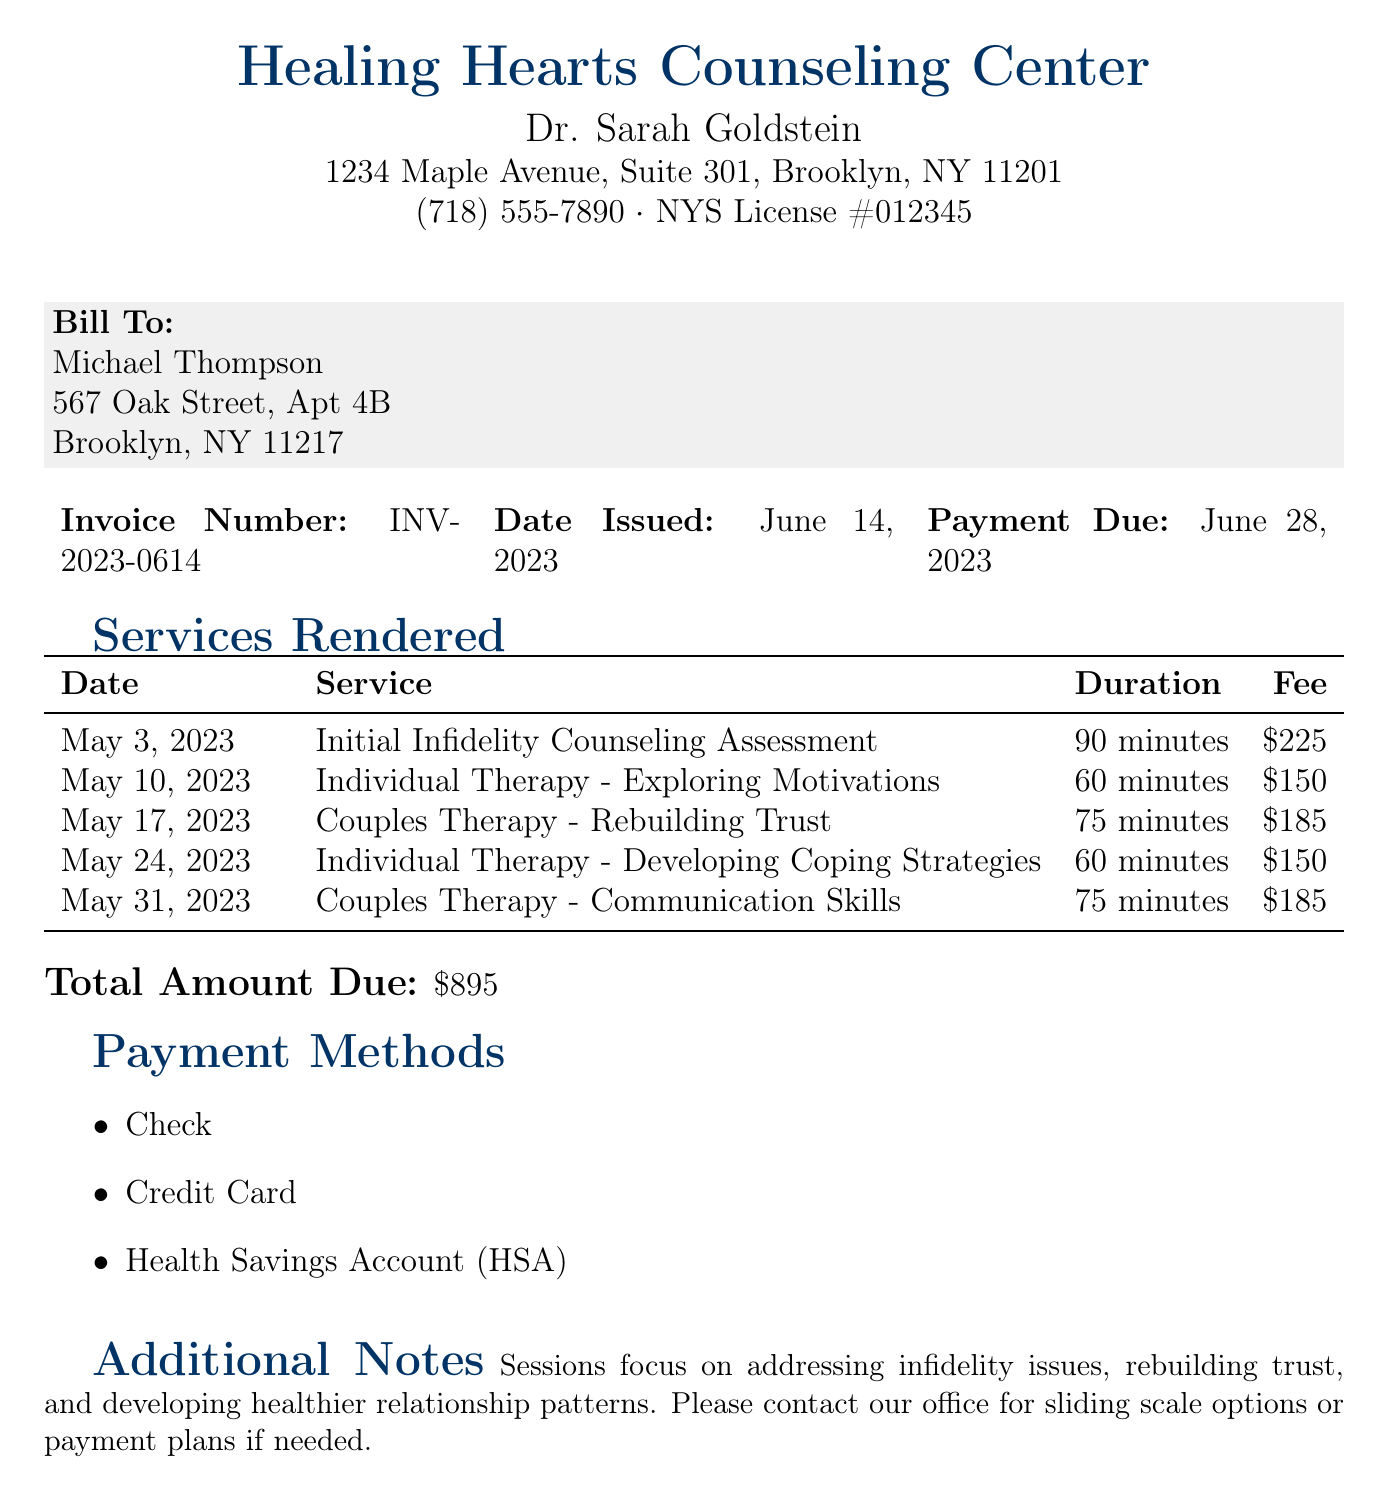What is the invoice number? The invoice number can be found in the header section of the document, listed as INV-2023-0614.
Answer: INV-2023-0614 Who is the bill addressed to? The 'Bill To' section clearly states the name of the person being billed, which is Michael Thompson.
Answer: Michael Thompson What is the total amount due? The total amount due is listed at the bottom of the document, which sums up all fees for the services provided.
Answer: $895 What is the duration of the initial counseling assessment? The duration is listed next to the date and service in the table, specifically stating 90 minutes for the initial assessment.
Answer: 90 minutes How many couples therapy sessions are included in the bill? By analyzing the services rendered, there are two entries listed for couples therapy sessions in the document.
Answer: 2 What payment methods are accepted? The payment methods can be found under the 'Payment Methods' section of the document, indicating multiple available options.
Answer: Check, Credit Card, Health Savings Account (HSA) What service took place on May 24, 2023? The date indicates that this was a session for 'Individual Therapy - Developing Coping Strategies.'
Answer: Individual Therapy - Developing Coping Strategies What is the fee for the session on May 31, 2023? The fee is listed next to the service details in the table, specifying $185 for that session.
Answer: $185 How long is the individual therapy session on May 10, 2023? The duration for the individual therapy session is indicated in the service table, which is 60 minutes.
Answer: 60 minutes 